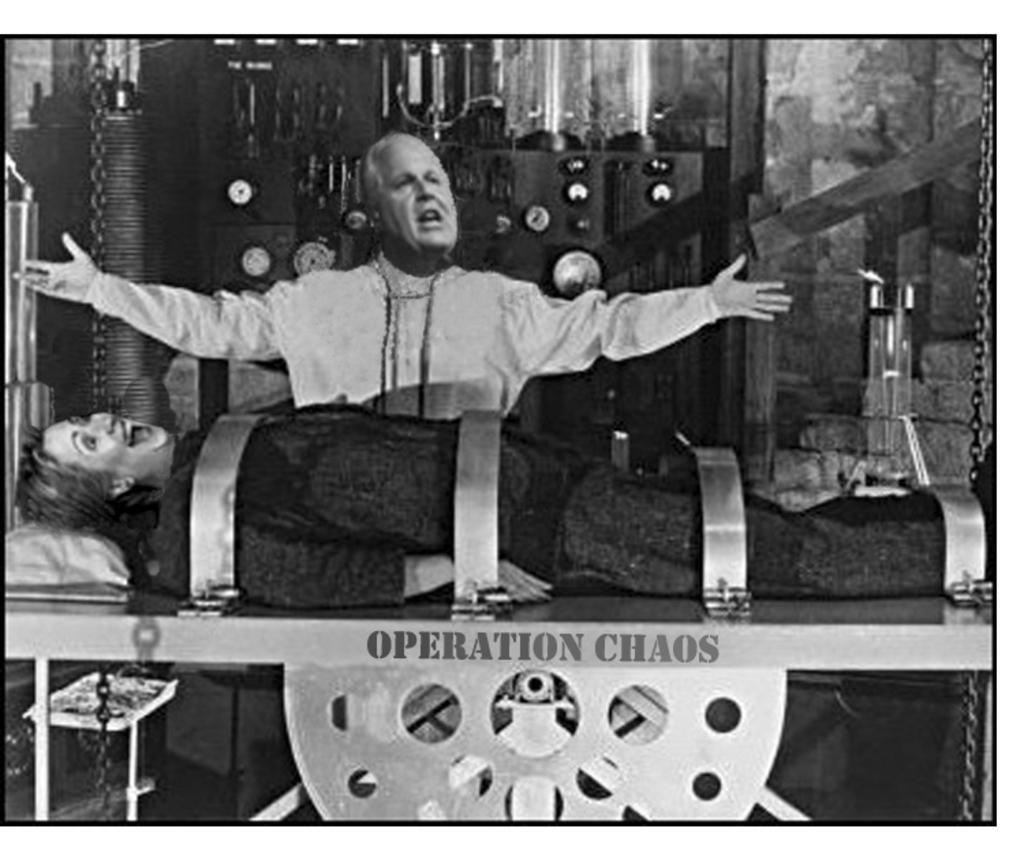Can you describe this image briefly? In this image there is a person laying on the metal board , and there are four iron rings on the person which are attached to the metal board , and at the background there is a person standing, machine. 